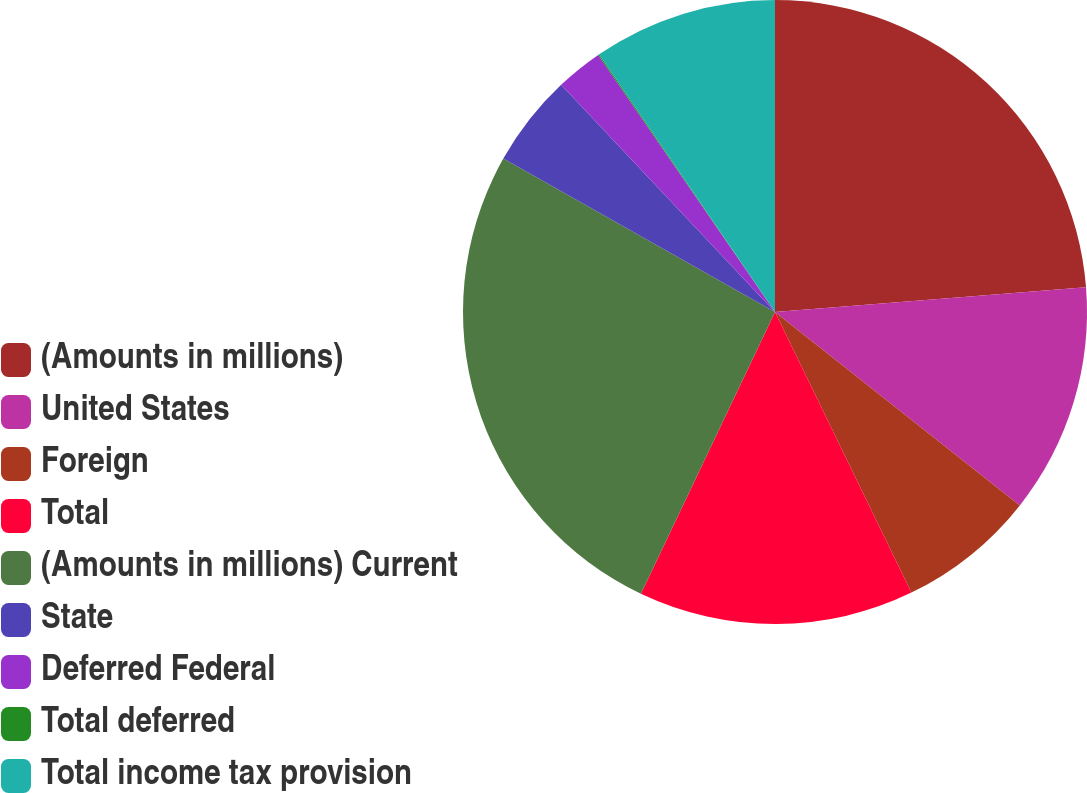Convert chart. <chart><loc_0><loc_0><loc_500><loc_500><pie_chart><fcel>(Amounts in millions)<fcel>United States<fcel>Foreign<fcel>Total<fcel>(Amounts in millions) Current<fcel>State<fcel>Deferred Federal<fcel>Total deferred<fcel>Total income tax provision<nl><fcel>23.74%<fcel>11.9%<fcel>7.16%<fcel>14.27%<fcel>26.11%<fcel>4.8%<fcel>2.43%<fcel>0.06%<fcel>9.53%<nl></chart> 